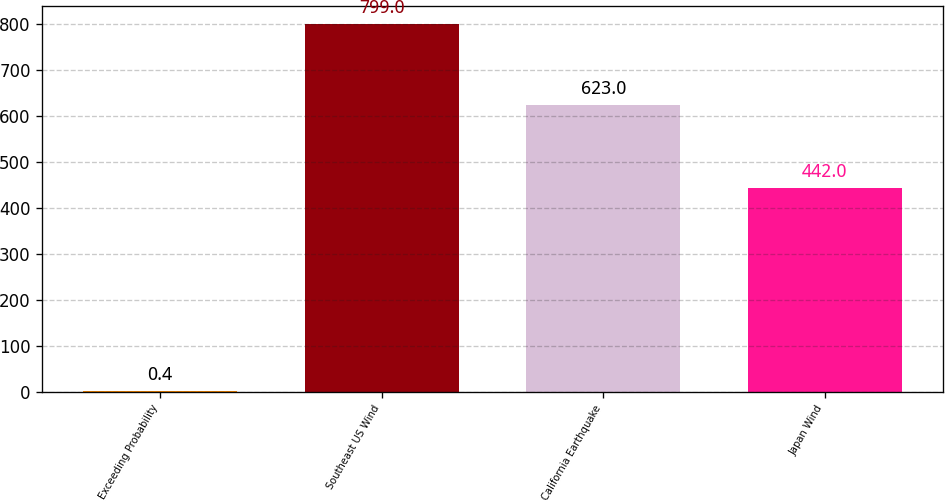<chart> <loc_0><loc_0><loc_500><loc_500><bar_chart><fcel>Exceeding Probability<fcel>Southeast US Wind<fcel>California Earthquake<fcel>Japan Wind<nl><fcel>0.4<fcel>799<fcel>623<fcel>442<nl></chart> 